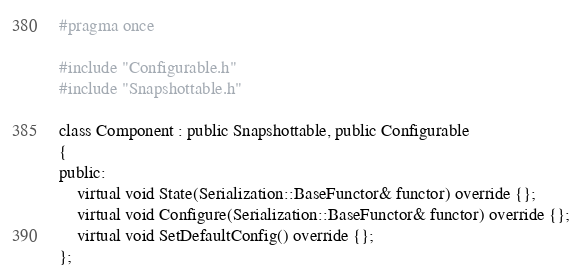<code> <loc_0><loc_0><loc_500><loc_500><_C_>#pragma once

#include "Configurable.h"
#include "Snapshottable.h"

class Component : public Snapshottable, public Configurable
{
public:
	virtual void State(Serialization::BaseFunctor& functor) override {};
	virtual void Configure(Serialization::BaseFunctor& functor) override {};
	virtual void SetDefaultConfig() override {};
};</code> 